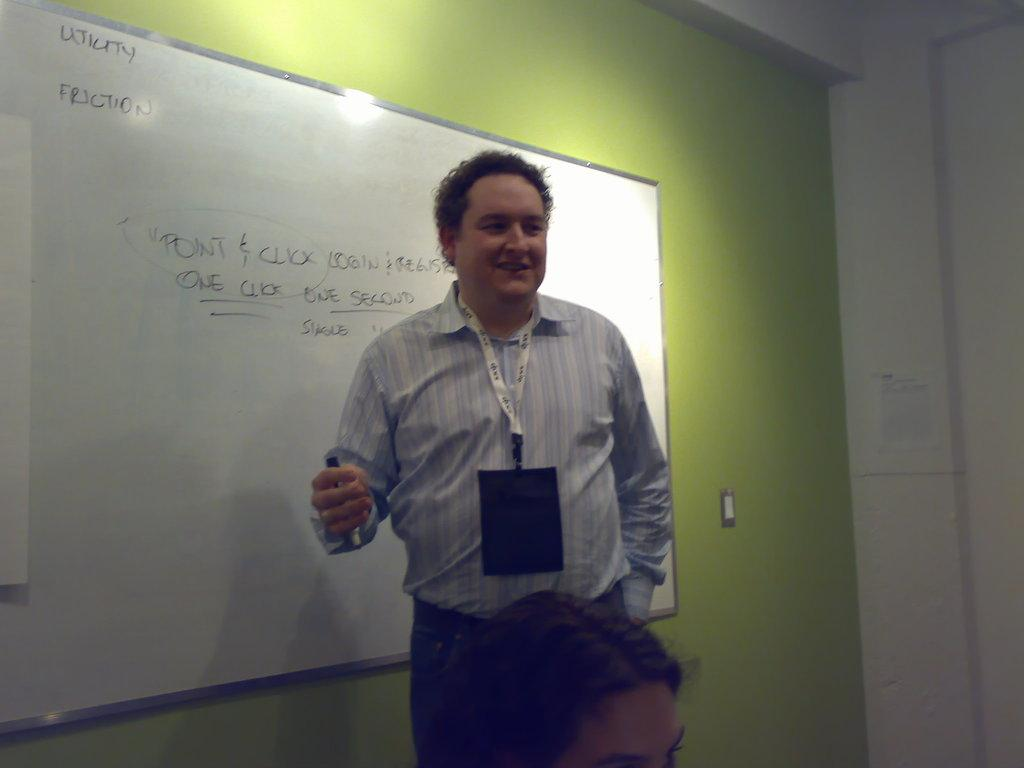<image>
Write a terse but informative summary of the picture. the word friction is on the white board next to the man 